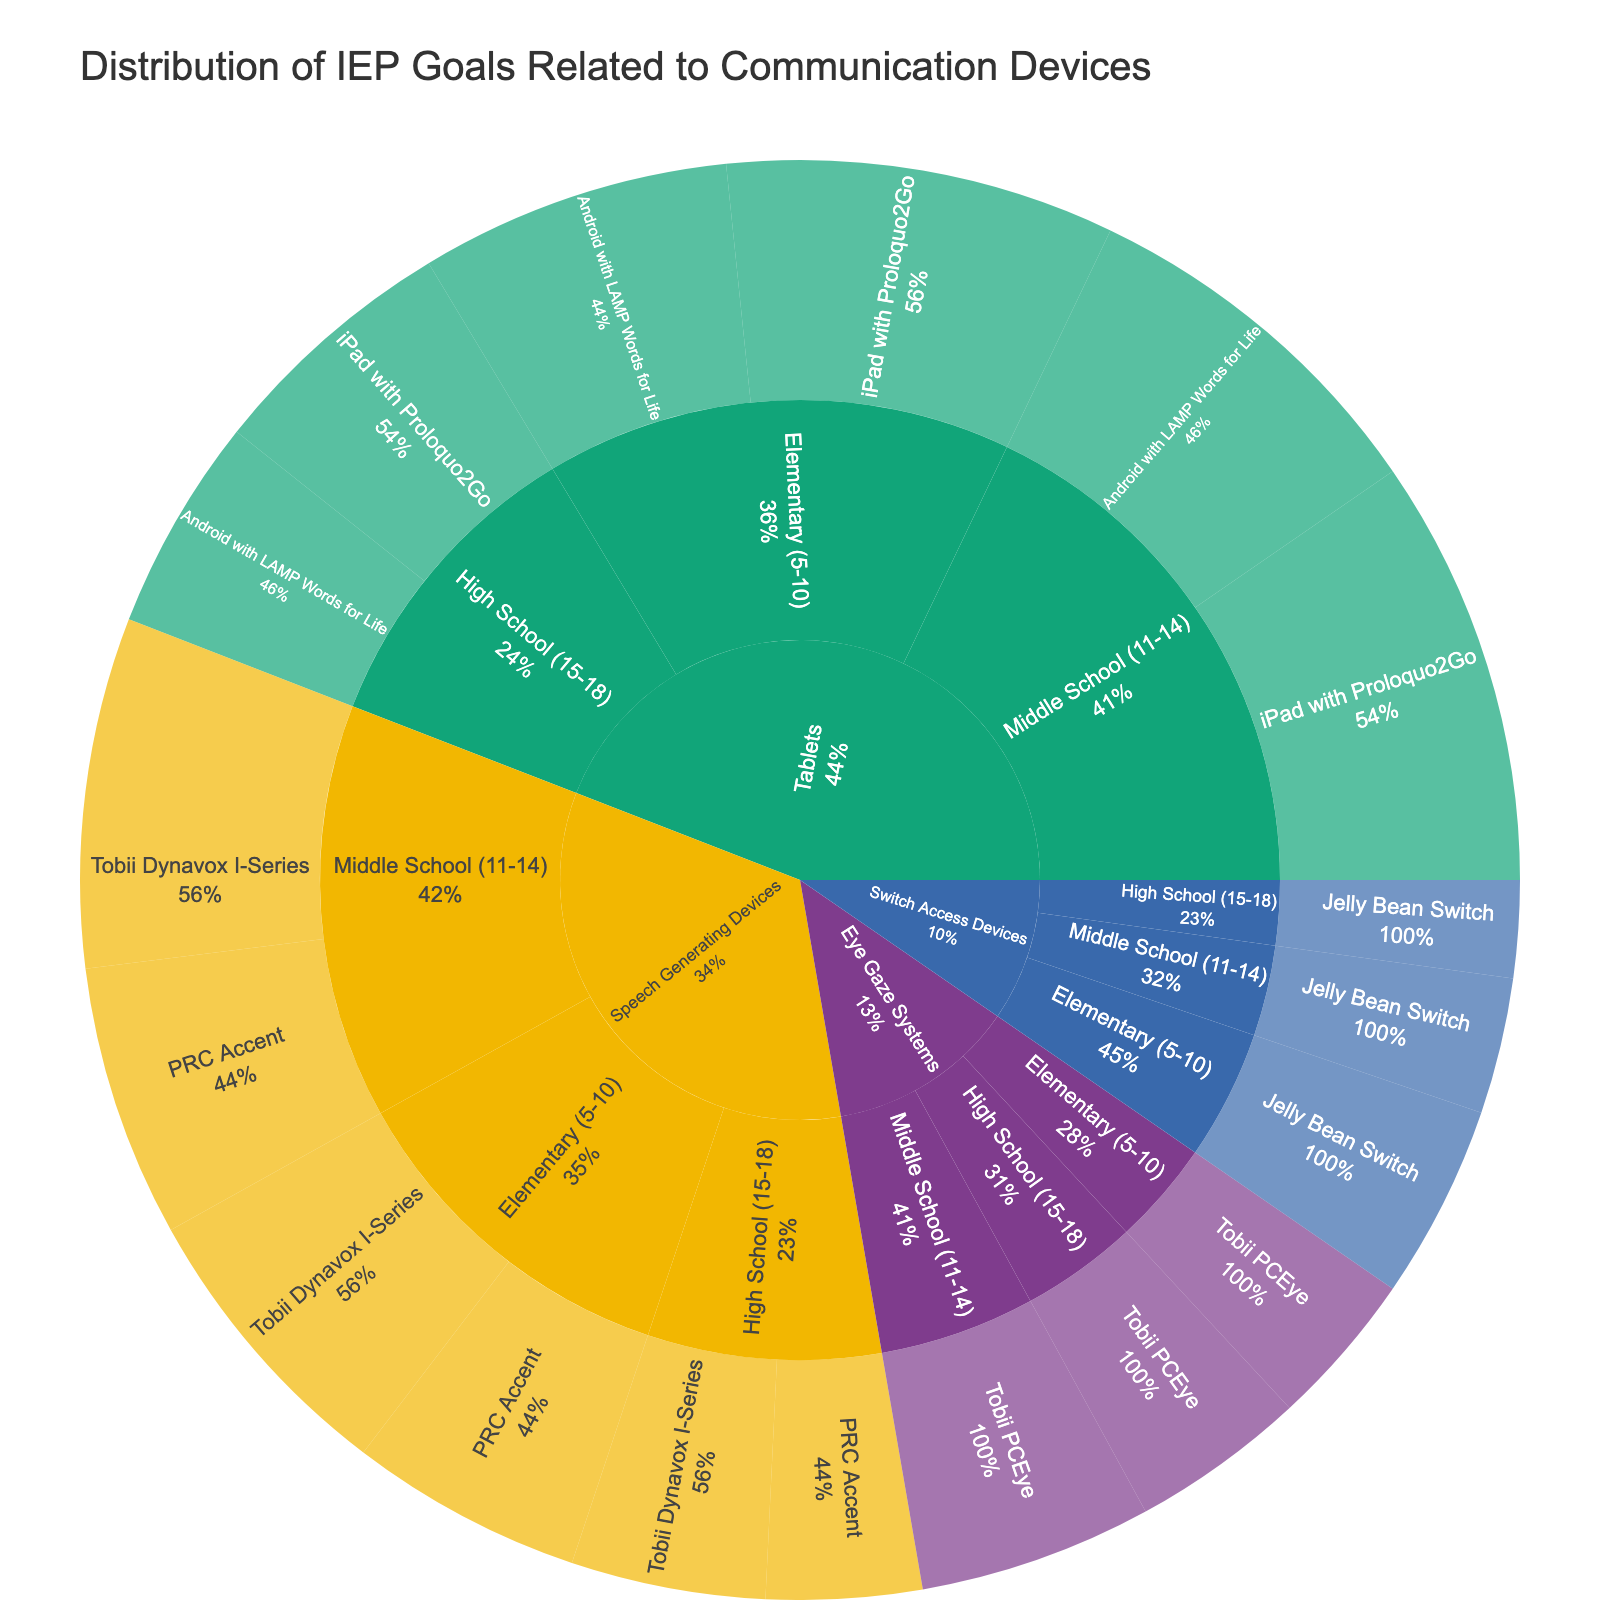How many IEP goals are associated with Tablets for Elementary (5-10) students? Look within the "Tablets" category, then find the segment for "Elementary (5-10)" age group. Sum the goals: iPad with Proloquo2Go (20) + Android with LAMP Words for Life (16) = 36
Answer: 36 Which device has the highest number of IEP goals among High School (15-18) students for speech-generating devices? In the Speech Generating Devices category for High School (15-18), compare the goals: Tobii Dynavox I-Series (10) and PRC Accent (8). Tobii Dynavox I-Series has the highest number of goals.
Answer: Tobii Dynavox I-Series What percentage of the total goals for Speech Generating Devices is contributed by Middle School (11-14) students? First, sum the goals for Middle School (11-14): Tobii Dynavox I-Series (18) + PRC Accent (14) = 32. Then sum the total goals for Speech Generating Devices: 15 (Elementary) + 12 (Elementary) + 18 (Middle School) + 14 (Middle School) + 10 (High School) + 8 (High School) = 77. The percentage is (32/77) * 100% = 41.56%.
Answer: 41.56% Which category has more IEP goals for High School (15-18) students: Tablets or Switch Access Devices? Compare the number of goals in High School (15-18): Tablets-iPad with Proloquo2Go (13) + Android with LAMP Words for Life (11) = 24, Switch Access Devices-Jelly Bean Switch (5). Tablets have more goals.
Answer: Tablets What is the total number of IEP goals associated with Eye Gaze Systems? Sum the goals in the Eye Gaze Systems category: Tobii PCEye (8) + Tobii PCEye (12) + Tobii PCEye (9) = 29
Answer: 29 For Elementary (5-10) students, which category has the fewest IEP goals? Compare the goals in the Elementary (5-10) age group across categories: Speech Generating Devices (15 + 12 = 27), Tablets (20 + 16 = 36), Eye Gaze Systems (8), Switch Access Devices (10). Eye Gaze Systems has the fewest goals.
Answer: Eye Gaze Systems Which specific device has the highest number of IEP goals across all age groups? Compare all devices' goals: iPad with Proloquo2Go (20 + 22 + 13 = 55), Tobii Dynavox I-Series (15 + 18 + 10 = 43), etc. iPad with Proloquo2Go has the highest with 55 goals.
Answer: iPad with Proloquo2Go How many more goals are there for Tablets in Middle School (11-14) compared to High School (15-18)? Sum the goals for Tablets: Middle School (iPad with Proloquo2Go: 22 + Android with LAMP Words for Life: 19 = 41), High School (iPad with Proloquo2Go: 13 + Android with LAMP Words for Life: 11 = 24). The difference is 41 - 24 = 17.
Answer: 17 What's the total number of IEP goals for Switch Access Devices in all age groups? Sum the Switch Access Devices goals: Elementary (10) + Middle School (7) + High School (5) = 22
Answer: 22 